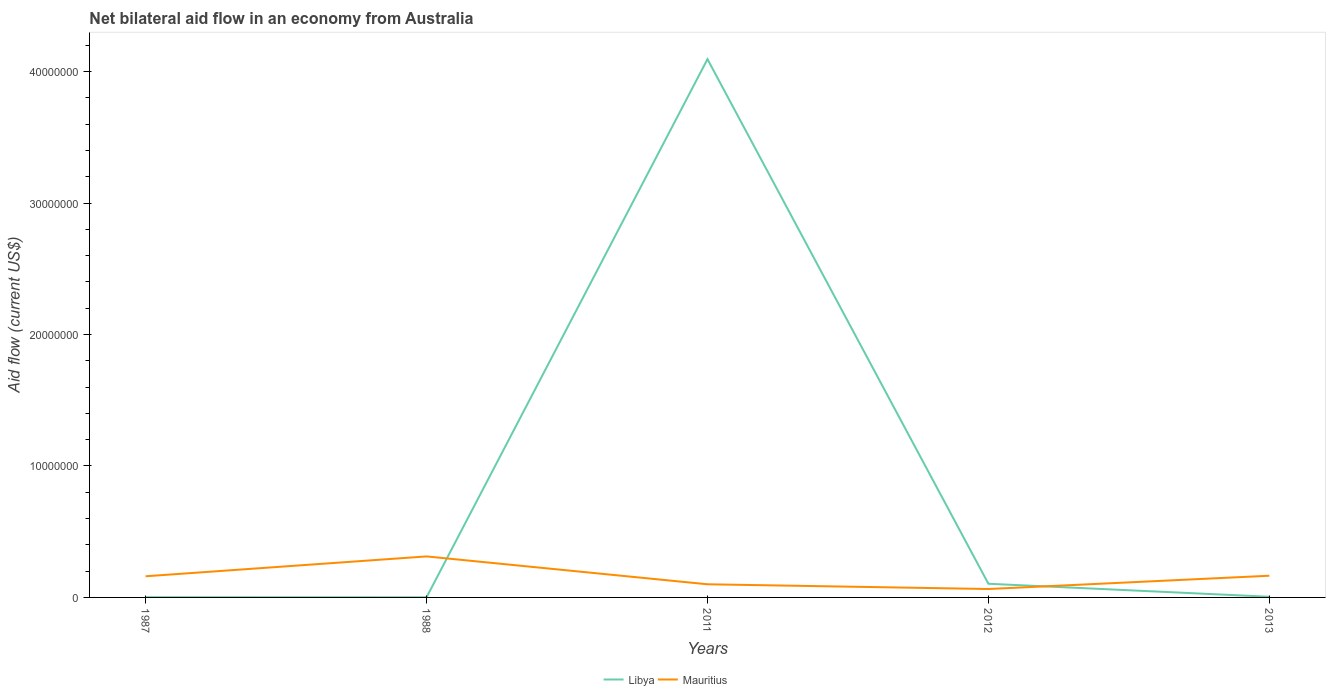How many different coloured lines are there?
Your response must be concise. 2. Does the line corresponding to Mauritius intersect with the line corresponding to Libya?
Provide a succinct answer. Yes. Is the number of lines equal to the number of legend labels?
Offer a terse response. Yes. Across all years, what is the maximum net bilateral aid flow in Mauritius?
Offer a very short reply. 6.40e+05. What is the total net bilateral aid flow in Libya in the graph?
Offer a very short reply. -1.02e+06. What is the difference between the highest and the second highest net bilateral aid flow in Libya?
Offer a terse response. 4.09e+07. Is the net bilateral aid flow in Mauritius strictly greater than the net bilateral aid flow in Libya over the years?
Keep it short and to the point. No. How many lines are there?
Provide a short and direct response. 2. Where does the legend appear in the graph?
Ensure brevity in your answer.  Bottom center. How many legend labels are there?
Keep it short and to the point. 2. How are the legend labels stacked?
Keep it short and to the point. Horizontal. What is the title of the graph?
Your response must be concise. Net bilateral aid flow in an economy from Australia. What is the label or title of the Y-axis?
Give a very brief answer. Aid flow (current US$). What is the Aid flow (current US$) in Mauritius in 1987?
Make the answer very short. 1.61e+06. What is the Aid flow (current US$) in Libya in 1988?
Your answer should be very brief. 10000. What is the Aid flow (current US$) in Mauritius in 1988?
Provide a succinct answer. 3.12e+06. What is the Aid flow (current US$) of Libya in 2011?
Offer a very short reply. 4.10e+07. What is the Aid flow (current US$) in Mauritius in 2011?
Keep it short and to the point. 1.00e+06. What is the Aid flow (current US$) in Libya in 2012?
Keep it short and to the point. 1.04e+06. What is the Aid flow (current US$) of Mauritius in 2012?
Keep it short and to the point. 6.40e+05. What is the Aid flow (current US$) in Mauritius in 2013?
Offer a terse response. 1.65e+06. Across all years, what is the maximum Aid flow (current US$) in Libya?
Provide a succinct answer. 4.10e+07. Across all years, what is the maximum Aid flow (current US$) in Mauritius?
Offer a very short reply. 3.12e+06. Across all years, what is the minimum Aid flow (current US$) in Libya?
Your response must be concise. 10000. Across all years, what is the minimum Aid flow (current US$) in Mauritius?
Provide a short and direct response. 6.40e+05. What is the total Aid flow (current US$) in Libya in the graph?
Provide a succinct answer. 4.21e+07. What is the total Aid flow (current US$) of Mauritius in the graph?
Provide a succinct answer. 8.02e+06. What is the difference between the Aid flow (current US$) in Mauritius in 1987 and that in 1988?
Your response must be concise. -1.51e+06. What is the difference between the Aid flow (current US$) in Libya in 1987 and that in 2011?
Ensure brevity in your answer.  -4.09e+07. What is the difference between the Aid flow (current US$) of Mauritius in 1987 and that in 2011?
Offer a very short reply. 6.10e+05. What is the difference between the Aid flow (current US$) in Libya in 1987 and that in 2012?
Your answer should be compact. -1.02e+06. What is the difference between the Aid flow (current US$) in Mauritius in 1987 and that in 2012?
Provide a succinct answer. 9.70e+05. What is the difference between the Aid flow (current US$) of Libya in 1987 and that in 2013?
Provide a succinct answer. -3.00e+04. What is the difference between the Aid flow (current US$) of Mauritius in 1987 and that in 2013?
Ensure brevity in your answer.  -4.00e+04. What is the difference between the Aid flow (current US$) of Libya in 1988 and that in 2011?
Your answer should be compact. -4.09e+07. What is the difference between the Aid flow (current US$) in Mauritius in 1988 and that in 2011?
Your answer should be very brief. 2.12e+06. What is the difference between the Aid flow (current US$) of Libya in 1988 and that in 2012?
Make the answer very short. -1.03e+06. What is the difference between the Aid flow (current US$) in Mauritius in 1988 and that in 2012?
Your answer should be very brief. 2.48e+06. What is the difference between the Aid flow (current US$) in Mauritius in 1988 and that in 2013?
Offer a terse response. 1.47e+06. What is the difference between the Aid flow (current US$) of Libya in 2011 and that in 2012?
Your answer should be compact. 3.99e+07. What is the difference between the Aid flow (current US$) of Libya in 2011 and that in 2013?
Offer a very short reply. 4.09e+07. What is the difference between the Aid flow (current US$) in Mauritius in 2011 and that in 2013?
Give a very brief answer. -6.50e+05. What is the difference between the Aid flow (current US$) of Libya in 2012 and that in 2013?
Offer a very short reply. 9.90e+05. What is the difference between the Aid flow (current US$) in Mauritius in 2012 and that in 2013?
Your answer should be compact. -1.01e+06. What is the difference between the Aid flow (current US$) in Libya in 1987 and the Aid flow (current US$) in Mauritius in 1988?
Provide a short and direct response. -3.10e+06. What is the difference between the Aid flow (current US$) of Libya in 1987 and the Aid flow (current US$) of Mauritius in 2011?
Your answer should be very brief. -9.80e+05. What is the difference between the Aid flow (current US$) of Libya in 1987 and the Aid flow (current US$) of Mauritius in 2012?
Your response must be concise. -6.20e+05. What is the difference between the Aid flow (current US$) of Libya in 1987 and the Aid flow (current US$) of Mauritius in 2013?
Your response must be concise. -1.63e+06. What is the difference between the Aid flow (current US$) of Libya in 1988 and the Aid flow (current US$) of Mauritius in 2011?
Offer a terse response. -9.90e+05. What is the difference between the Aid flow (current US$) of Libya in 1988 and the Aid flow (current US$) of Mauritius in 2012?
Provide a succinct answer. -6.30e+05. What is the difference between the Aid flow (current US$) in Libya in 1988 and the Aid flow (current US$) in Mauritius in 2013?
Provide a short and direct response. -1.64e+06. What is the difference between the Aid flow (current US$) in Libya in 2011 and the Aid flow (current US$) in Mauritius in 2012?
Ensure brevity in your answer.  4.03e+07. What is the difference between the Aid flow (current US$) of Libya in 2011 and the Aid flow (current US$) of Mauritius in 2013?
Provide a succinct answer. 3.93e+07. What is the difference between the Aid flow (current US$) in Libya in 2012 and the Aid flow (current US$) in Mauritius in 2013?
Your answer should be very brief. -6.10e+05. What is the average Aid flow (current US$) of Libya per year?
Ensure brevity in your answer.  8.41e+06. What is the average Aid flow (current US$) of Mauritius per year?
Keep it short and to the point. 1.60e+06. In the year 1987, what is the difference between the Aid flow (current US$) of Libya and Aid flow (current US$) of Mauritius?
Keep it short and to the point. -1.59e+06. In the year 1988, what is the difference between the Aid flow (current US$) in Libya and Aid flow (current US$) in Mauritius?
Your response must be concise. -3.11e+06. In the year 2011, what is the difference between the Aid flow (current US$) in Libya and Aid flow (current US$) in Mauritius?
Ensure brevity in your answer.  4.00e+07. In the year 2013, what is the difference between the Aid flow (current US$) in Libya and Aid flow (current US$) in Mauritius?
Keep it short and to the point. -1.60e+06. What is the ratio of the Aid flow (current US$) of Mauritius in 1987 to that in 1988?
Your answer should be compact. 0.52. What is the ratio of the Aid flow (current US$) in Mauritius in 1987 to that in 2011?
Offer a terse response. 1.61. What is the ratio of the Aid flow (current US$) of Libya in 1987 to that in 2012?
Your answer should be compact. 0.02. What is the ratio of the Aid flow (current US$) of Mauritius in 1987 to that in 2012?
Ensure brevity in your answer.  2.52. What is the ratio of the Aid flow (current US$) in Mauritius in 1987 to that in 2013?
Provide a succinct answer. 0.98. What is the ratio of the Aid flow (current US$) in Libya in 1988 to that in 2011?
Give a very brief answer. 0. What is the ratio of the Aid flow (current US$) in Mauritius in 1988 to that in 2011?
Your answer should be compact. 3.12. What is the ratio of the Aid flow (current US$) in Libya in 1988 to that in 2012?
Provide a short and direct response. 0.01. What is the ratio of the Aid flow (current US$) in Mauritius in 1988 to that in 2012?
Give a very brief answer. 4.88. What is the ratio of the Aid flow (current US$) of Libya in 1988 to that in 2013?
Make the answer very short. 0.2. What is the ratio of the Aid flow (current US$) in Mauritius in 1988 to that in 2013?
Offer a terse response. 1.89. What is the ratio of the Aid flow (current US$) of Libya in 2011 to that in 2012?
Your answer should be very brief. 39.38. What is the ratio of the Aid flow (current US$) in Mauritius in 2011 to that in 2012?
Keep it short and to the point. 1.56. What is the ratio of the Aid flow (current US$) of Libya in 2011 to that in 2013?
Ensure brevity in your answer.  819. What is the ratio of the Aid flow (current US$) of Mauritius in 2011 to that in 2013?
Offer a terse response. 0.61. What is the ratio of the Aid flow (current US$) in Libya in 2012 to that in 2013?
Offer a very short reply. 20.8. What is the ratio of the Aid flow (current US$) in Mauritius in 2012 to that in 2013?
Your answer should be very brief. 0.39. What is the difference between the highest and the second highest Aid flow (current US$) of Libya?
Your answer should be compact. 3.99e+07. What is the difference between the highest and the second highest Aid flow (current US$) in Mauritius?
Provide a succinct answer. 1.47e+06. What is the difference between the highest and the lowest Aid flow (current US$) in Libya?
Keep it short and to the point. 4.09e+07. What is the difference between the highest and the lowest Aid flow (current US$) of Mauritius?
Your response must be concise. 2.48e+06. 